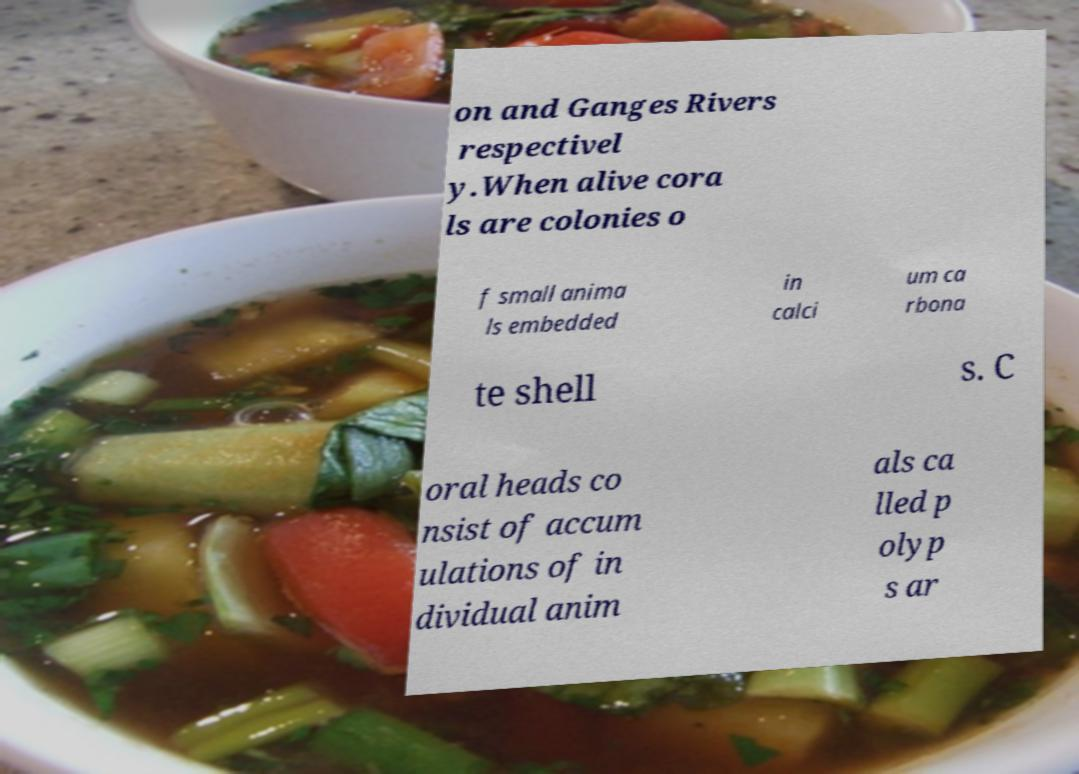Please identify and transcribe the text found in this image. on and Ganges Rivers respectivel y.When alive cora ls are colonies o f small anima ls embedded in calci um ca rbona te shell s. C oral heads co nsist of accum ulations of in dividual anim als ca lled p olyp s ar 